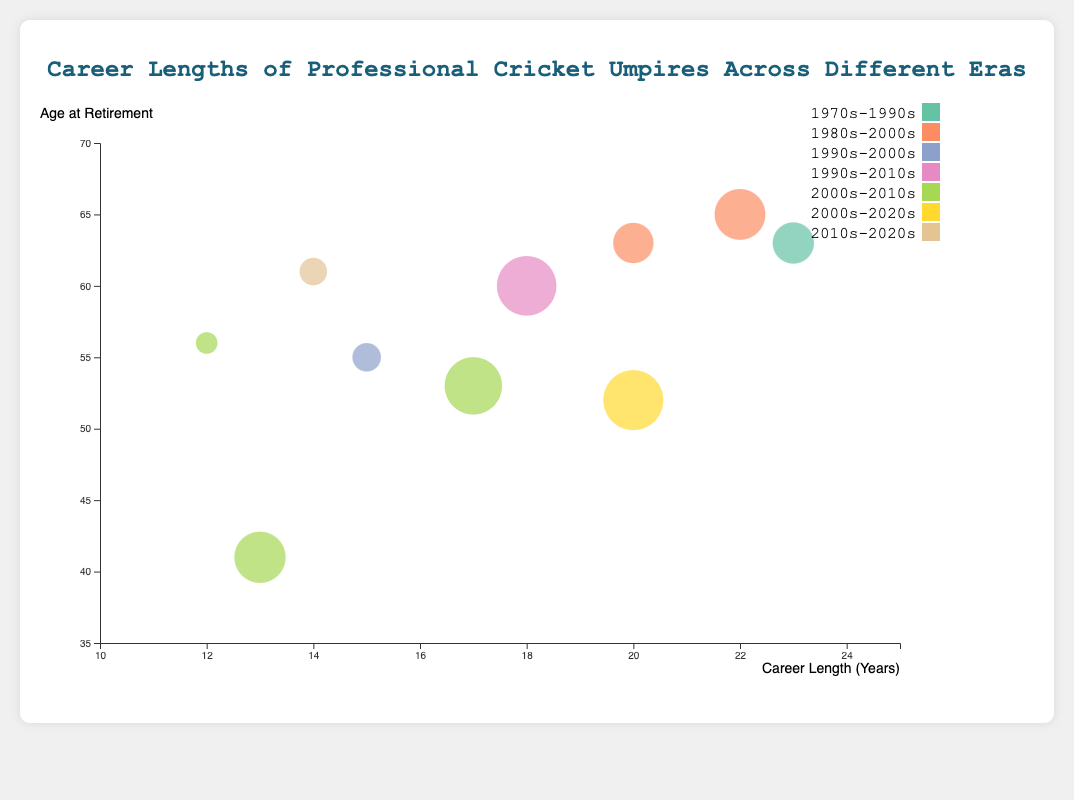What is the title of the chart? The title of the chart is the text at the very top of the figure. It usually summarizes what the chart is about.
Answer: Career Lengths of Professional Cricket Umpires Across Different Eras How many different eras are represented in the chart? Different eras are represented by different colors in the chart. Count the unique colors in the legend.
Answer: 7 Which umpire had the longest career length? The X-axis represents career lengths. The umpire with the longest career will have the bubble furthest to the right. Dickie Bird has the bubble furthest to the right, indicating a career length of 23 years.
Answer: Dickie Bird Who retired at the youngest age? The Y-axis represents age at retirement. The bubble lowest on the Y-axis represents the youngest age at retirement. Simon Taufel's bubble is at the lowest Y-axis value, indicating he retired at age 41.
Answer: Simon Taufel Which umpire officiated the most matches? Bubble size represents the number of matches officiated. The largest bubble in the chart corresponds to Aleem Dar.
Answer: Aleem Dar What is the average age at retirement for umpires whose career lengths are more than 20 years? Identify bubbles with career lengths more than 20 years (20, 22, 23) and calculate the average of their ages at retirement: (63 + 65 + 63) / 3 = 63.67
Answer: 63.67 Compare Aleem Dar and Billy Bowden in terms of career length and matches officiated. Who had a longer career, and who officiated more matches? Aleem Dar and Billy Bowden both have similar-sized bubbles close on the X-axis. However, Aleem Dar's bubble is larger and shows he officiated more matches than Billy Bowden. Aleem Dar's career length is 20 years, and Billy Bowden's is 17 years; Aleem Dar also officiated 211 matches compared to Billy Bowden's 200.
Answer: Aleem Dar had a longer career and officiated more matches Between the umpires who officiated over 150 matches, who retired at the oldest age? Look for the largest bubbles and identify the ones over 150 matches officiated. Compare their positions on the Y-axis to find the highest value. David Shepherd officiated more than 150 matches and retired at age 65.
Answer: David Shepherd What is the median age at retirement for the umpires listed in the chart? List all ages at retirement (63, 41, 65, 63, 52, 53, 60, 55, 56, 61), sort them (41, 52, 53, 55, 56, 60, 61, 63, 63, 65) and find the middle value. Since there are 10 values, the median is the average of the 5th and 6th values: (56 + 60) / 2 = 58.
Answer: 58 Which era saw more umpires retiring at an older age (above 60)? Identify eras for umpires retiring above age 60 from the Y-axis values. Count occurrences for each era: (1970s-1990s: 1, 1980s-2000s: 1, 2010s-2020s: 1, 1990s-2010s: 1). All these eras have one umpire each, so they are tied.
Answer: 1970s-1990s, 1980s-2000s, 2010s-2020s, 1990s-2010s 